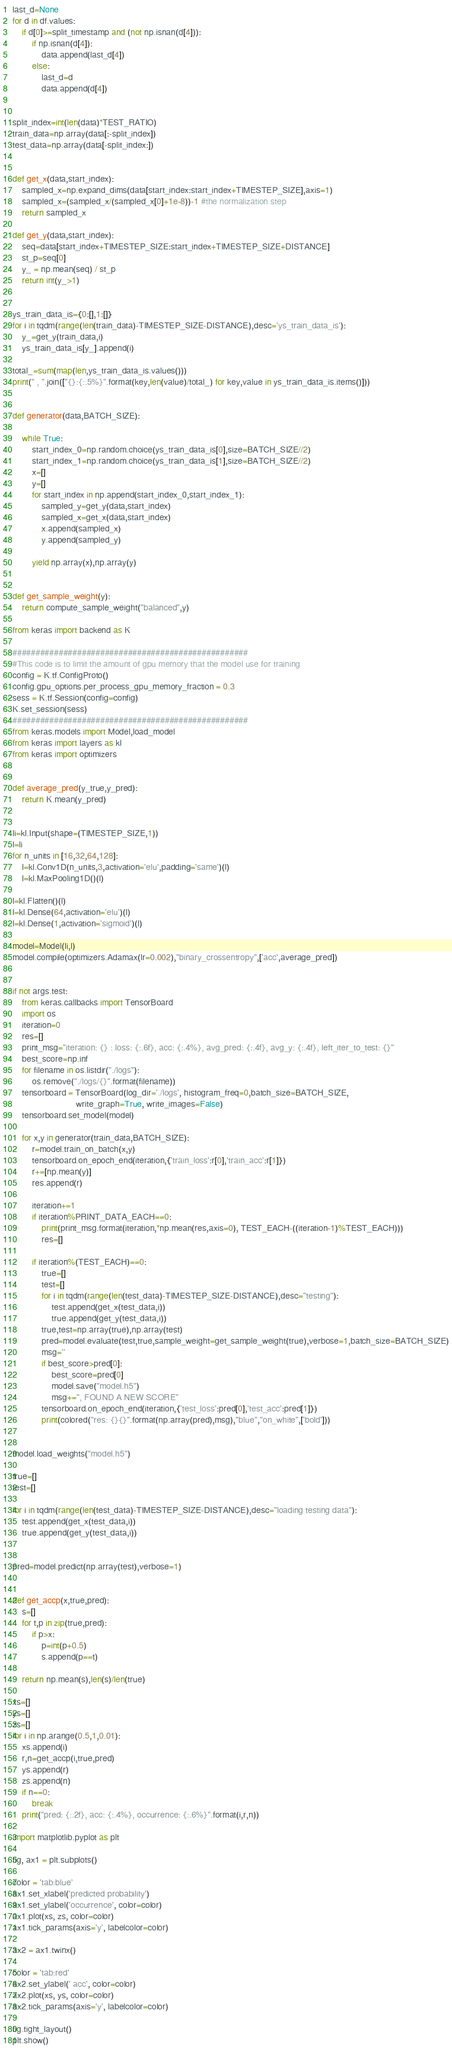Convert code to text. <code><loc_0><loc_0><loc_500><loc_500><_Python_>last_d=None
for d in df.values:
	if d[0]>=split_timestamp and (not np.isnan(d[4])):
		if np.isnan(d[4]):
			data.append(last_d[4])
		else:
			last_d=d
			data.append(d[4])


split_index=int(len(data)*TEST_RATIO)
train_data=np.array(data[:-split_index])
test_data=np.array(data[-split_index:])


def get_x(data,start_index):
	sampled_x=np.expand_dims(data[start_index:start_index+TIMESTEP_SIZE],axis=1)
	sampled_x=(sampled_x/(sampled_x[0]+1e-8))-1 #the normalization step
	return sampled_x

def get_y(data,start_index):
	seq=data[start_index+TIMESTEP_SIZE:start_index+TIMESTEP_SIZE+DISTANCE]
	st_p=seq[0]
	y_ = np.mean(seq) / st_p
	return int(y_>1)


ys_train_data_is={0:[],1:[]}
for i in tqdm(range(len(train_data)-TIMESTEP_SIZE-DISTANCE),desc='ys_train_data_is'):
	y_=get_y(train_data,i)
	ys_train_data_is[y_].append(i)

total_=sum(map(len,ys_train_data_is.values()))
print(" , ".join(["{}:{:.5%}".format(key,len(value)/total_) for key,value in ys_train_data_is.items()]))


def generator(data,BATCH_SIZE):

	while True:
		start_index_0=np.random.choice(ys_train_data_is[0],size=BATCH_SIZE//2)
		start_index_1=np.random.choice(ys_train_data_is[1],size=BATCH_SIZE//2)
		x=[]
		y=[]
		for start_index in np.append(start_index_0,start_index_1):
			sampled_y=get_y(data,start_index)
			sampled_x=get_x(data,start_index)
			x.append(sampled_x)
			y.append(sampled_y)

		yield np.array(x),np.array(y)


def get_sample_weight(y):
	return compute_sample_weight("balanced",y)

from keras import backend as K

###################################################
#This code is to limit the amount of gpu memory that the model use for training
config = K.tf.ConfigProto()
config.gpu_options.per_process_gpu_memory_fraction = 0.3
sess = K.tf.Session(config=config)
K.set_session(sess)
###################################################
from keras.models import Model,load_model
from keras import layers as kl 
from keras import optimizers


def average_pred(y_true,y_pred):
	return K.mean(y_pred)


li=kl.Input(shape=(TIMESTEP_SIZE,1))
l=li
for n_units in [16,32,64,128]:
	l=kl.Conv1D(n_units,3,activation='elu',padding='same')(l)
	l=kl.MaxPooling1D()(l)

l=kl.Flatten()(l)
l=kl.Dense(64,activation='elu')(l)
l=kl.Dense(1,activation='sigmoid')(l)

model=Model(li,l)
model.compile(optimizers.Adamax(lr=0.002),"binary_crossentropy",['acc',average_pred])


if not args.test:
	from keras.callbacks import TensorBoard
	import os
	iteration=0
	res=[]
	print_msg="iteration: {} : loss: {:.6f}, acc: {:.4%}, avg_pred: {:.4f}, avg_y: {:.4f}, left_iter_to_test: {}"
	best_score=np.inf
	for filename in os.listdir("./logs"):
		os.remove("./logs/{}".format(filename))
	tensorboard = TensorBoard(log_dir='./logs', histogram_freq=0,batch_size=BATCH_SIZE,
						  write_graph=True, write_images=False)
	tensorboard.set_model(model)

	for x,y in generator(train_data,BATCH_SIZE):
		r=model.train_on_batch(x,y)
		tensorboard.on_epoch_end(iteration,{'train_loss':r[0],'train_acc':r[1]})
		r+=[np.mean(y)]
		res.append(r)

		iteration+=1
		if iteration%PRINT_DATA_EACH==0:
			print(print_msg.format(iteration,*np.mean(res,axis=0), TEST_EACH-((iteration-1)%TEST_EACH)))
			res=[]

		if iteration%(TEST_EACH)==0:
			true=[]
			test=[]
			for i in tqdm(range(len(test_data)-TIMESTEP_SIZE-DISTANCE),desc="testing"):
				test.append(get_x(test_data,i))
				true.append(get_y(test_data,i))
			true,test=np.array(true),np.array(test)
			pred=model.evaluate(test,true,sample_weight=get_sample_weight(true),verbose=1,batch_size=BATCH_SIZE)
			msg=''
			if best_score>pred[0]:
				best_score=pred[0]
				model.save("model.h5")
				msg+=", FOUND A NEW SCORE"
			tensorboard.on_epoch_end(iteration,{'test_loss':pred[0],'test_acc':pred[1]})
			print(colored("res: {}{}".format(np.array(pred),msg),"blue","on_white",['bold']))


model.load_weights("model.h5")

true=[]
test=[]

for i in tqdm(range(len(test_data)-TIMESTEP_SIZE-DISTANCE),desc="loading testing data"):
	test.append(get_x(test_data,i))
	true.append(get_y(test_data,i))


pred=model.predict(np.array(test),verbose=1)


def get_accp(x,true,pred):
	s=[]
	for t,p in zip(true,pred):
		if p>x:
			p=int(p+0.5)
			s.append(p==t)

	return np.mean(s),len(s)/len(true)

xs=[]
ys=[]
zs=[]
for i in np.arange(0.5,1,0.01):
	xs.append(i)
	r,n=get_accp(i,true,pred)
	ys.append(r)
	zs.append(n)
	if n==0:
		break
	print("pred: {:.2f}, acc: {:.4%}, occurrence: {:.6%}".format(i,r,n))

import matplotlib.pyplot as plt

fig, ax1 = plt.subplots()

color = 'tab:blue'
ax1.set_xlabel('predicted probability')
ax1.set_ylabel('occurrence', color=color)
ax1.plot(xs, zs, color=color)
ax1.tick_params(axis='y', labelcolor=color)

ax2 = ax1.twinx()

color = 'tab:red'
ax2.set_ylabel(' acc', color=color)
ax2.plot(xs, ys, color=color)
ax2.tick_params(axis='y', labelcolor=color)

fig.tight_layout()
plt.show()</code> 